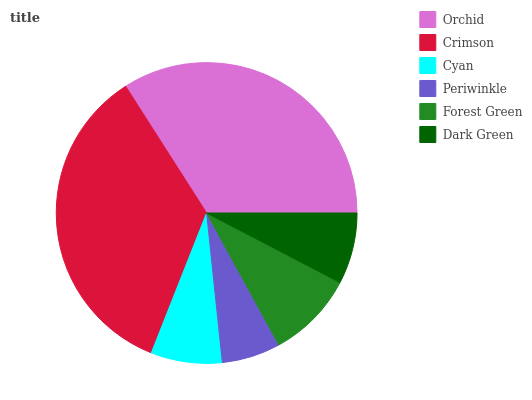Is Periwinkle the minimum?
Answer yes or no. Yes. Is Crimson the maximum?
Answer yes or no. Yes. Is Cyan the minimum?
Answer yes or no. No. Is Cyan the maximum?
Answer yes or no. No. Is Crimson greater than Cyan?
Answer yes or no. Yes. Is Cyan less than Crimson?
Answer yes or no. Yes. Is Cyan greater than Crimson?
Answer yes or no. No. Is Crimson less than Cyan?
Answer yes or no. No. Is Forest Green the high median?
Answer yes or no. Yes. Is Cyan the low median?
Answer yes or no. Yes. Is Cyan the high median?
Answer yes or no. No. Is Crimson the low median?
Answer yes or no. No. 